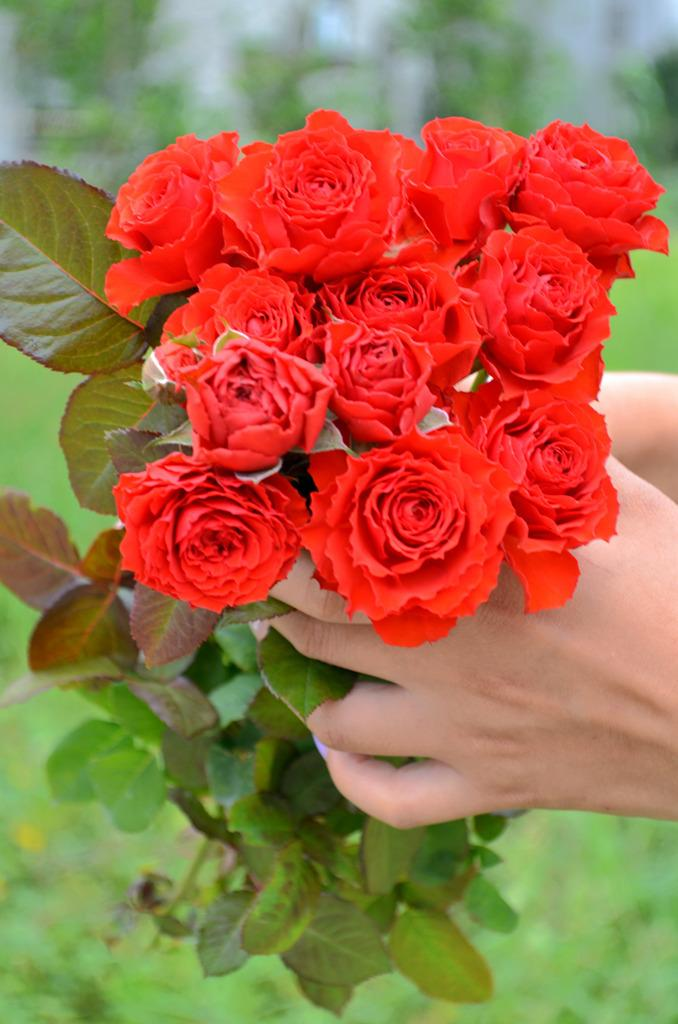Who or what is present in the image? There is a person in the image. What is the person holding in their hands? The person is holding flowers and leaves. Can you describe the background of the image? The background of the image is blurred. What type of card is the goat holding in the image? There is no goat or card present in the image. 